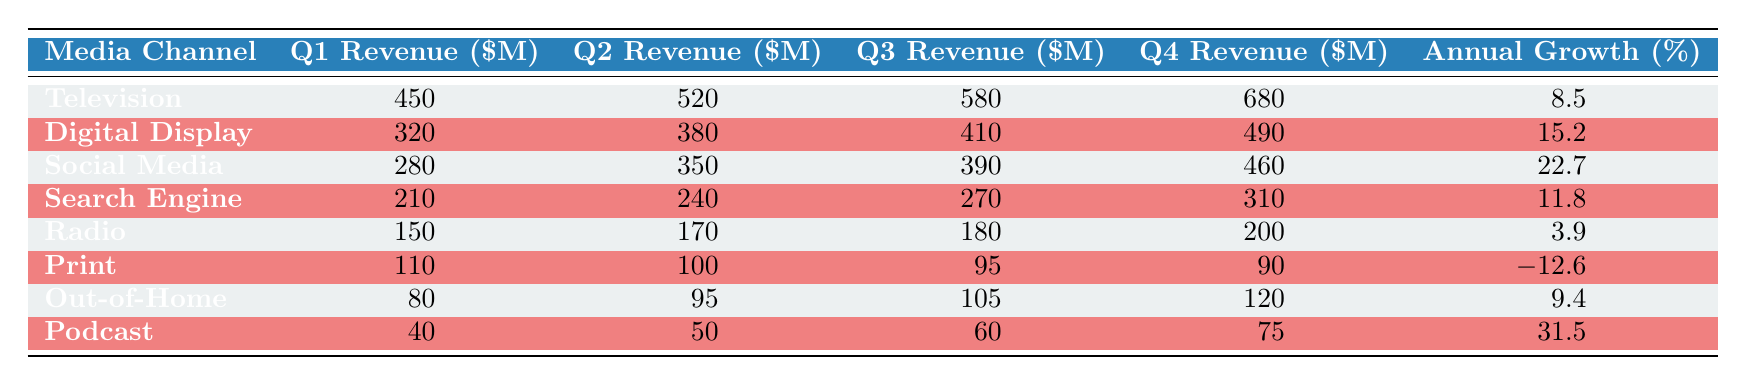What was the revenue for Television in Q4? The table shows that the revenue for Television in Q4 is 680 million dollars.
Answer: 680 Which media channel had the highest annual growth percentage? By comparing the 'Annual Growth (%)' column, Social Media has the highest value at 22.7%.
Answer: Social Media What is the total revenue for Digital Display across all quarters? To find the total, add the quarterly revenues: 320 + 380 + 410 + 490 = 1600 million dollars.
Answer: 1600 Is the revenue for Print in Q4 greater than that for Podcast in Q4? The revenue for Print in Q4 is 90 million dollars, while for Podcast it is 75 million dollars. Since 90 is greater than 75, the statement is true.
Answer: Yes Which media channel had lower annual growth, Radio or Search Engine? Radio has an annual growth of 3.9% and Search Engine has 11.8%. Therefore, Radio has lower growth compared to Search Engine.
Answer: Radio What is the average quarterly revenue for Out-of-Home? The average is calculated by adding the quarterly revenues (80 + 95 + 105 + 120 = 400 million dollars) and dividing by 4, which results in 100 million dollars.
Answer: 100 How much more revenue did Social Media generate in Q3 compared to Television? Social Media's revenue in Q3 is 390 million dollars, while Television's is 580 million dollars. To find the difference, subtract: 390 - 580 = -190 million dollars, indicating Social Media generated 190 million less.
Answer: 190 less Which media channel generated exactly 150 million dollars in Q1? Referring to the table, Radio generated 150 million dollars in Q1.
Answer: Radio Did Podcast have an increase or decrease in revenue from Q2 to Q3? Podcast's revenue increased from 50 million in Q2 to 60 million in Q3, indicating an increase.
Answer: Increase 